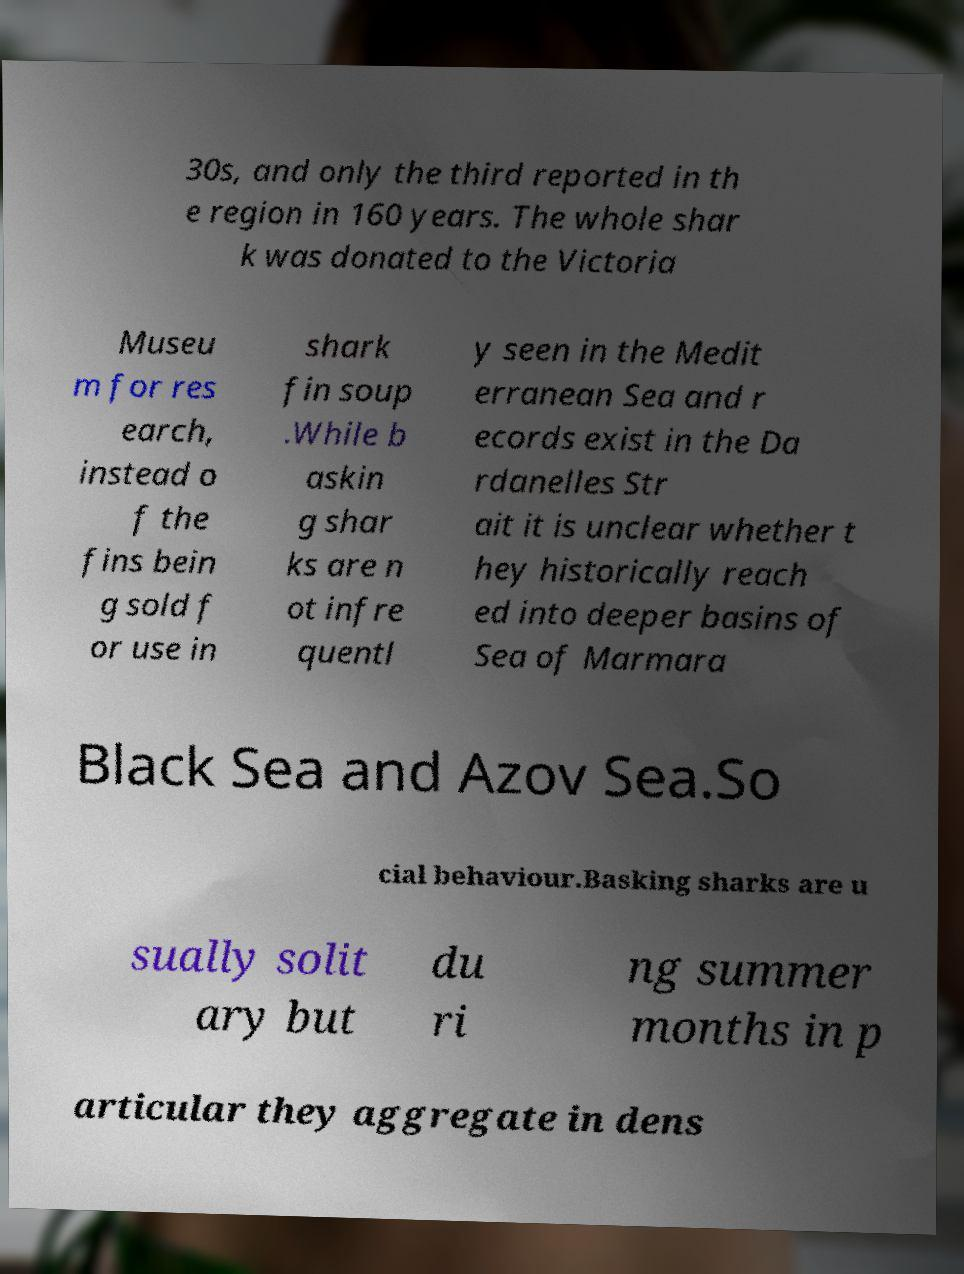Could you extract and type out the text from this image? 30s, and only the third reported in th e region in 160 years. The whole shar k was donated to the Victoria Museu m for res earch, instead o f the fins bein g sold f or use in shark fin soup .While b askin g shar ks are n ot infre quentl y seen in the Medit erranean Sea and r ecords exist in the Da rdanelles Str ait it is unclear whether t hey historically reach ed into deeper basins of Sea of Marmara Black Sea and Azov Sea.So cial behaviour.Basking sharks are u sually solit ary but du ri ng summer months in p articular they aggregate in dens 